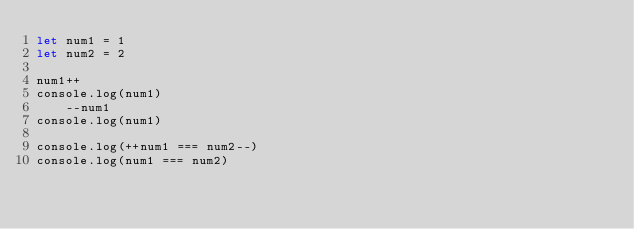<code> <loc_0><loc_0><loc_500><loc_500><_JavaScript_>let num1 = 1
let num2 = 2

num1++
console.log(num1)
    --num1
console.log(num1)

console.log(++num1 === num2--)
console.log(num1 === num2)</code> 